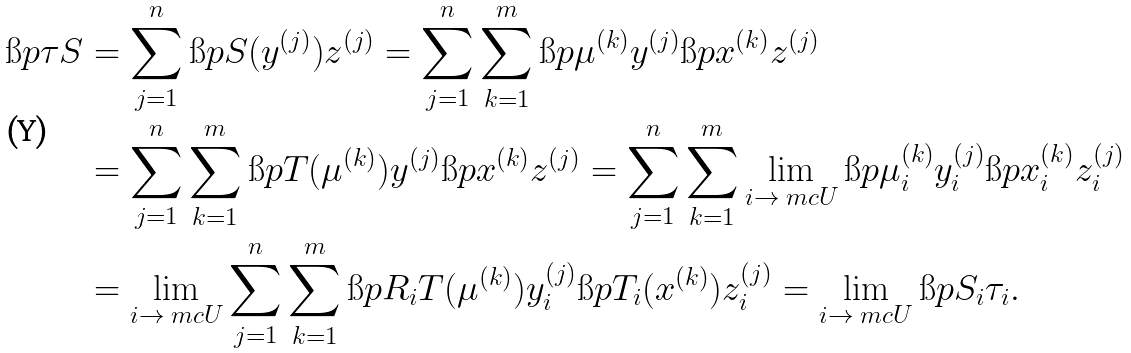Convert formula to latex. <formula><loc_0><loc_0><loc_500><loc_500>\i p { \tau } { S } & = \sum _ { j = 1 } ^ { n } \i p { S ( y ^ { ( j ) } ) } { z ^ { ( j ) } } = \sum _ { j = 1 } ^ { n } \sum _ { k = 1 } ^ { m } \i p { \mu ^ { ( k ) } } { y ^ { ( j ) } } \i p { x ^ { ( k ) } } { z ^ { ( j ) } } \\ & = \sum _ { j = 1 } ^ { n } \sum _ { k = 1 } ^ { m } \i p { T ( \mu ^ { ( k ) } ) } { y ^ { ( j ) } } \i p { x ^ { ( k ) } } { z ^ { ( j ) } } = \sum _ { j = 1 } ^ { n } \sum _ { k = 1 } ^ { m } \lim _ { i \rightarrow \ m c U } \i p { \mu ^ { ( k ) } _ { i } } { y ^ { ( j ) } _ { i } } \i p { x ^ { ( k ) } _ { i } } { z ^ { ( j ) } _ { i } } \\ & = \lim _ { i \rightarrow \ m c U } \sum _ { j = 1 } ^ { n } \sum _ { k = 1 } ^ { m } \i p { R _ { i } T ( \mu ^ { ( k ) } ) } { y ^ { ( j ) } _ { i } } \i p { T _ { i } ( x ^ { ( k ) } ) } { z ^ { ( j ) } _ { i } } = \lim _ { i \rightarrow \ m c U } \i p { S _ { i } } { \tau _ { i } } .</formula> 